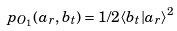Convert formula to latex. <formula><loc_0><loc_0><loc_500><loc_500>p _ { O _ { 1 } } ( a _ { r } , b _ { t } ) = 1 / 2 \langle b _ { t } | a _ { r } \rangle ^ { 2 }</formula> 